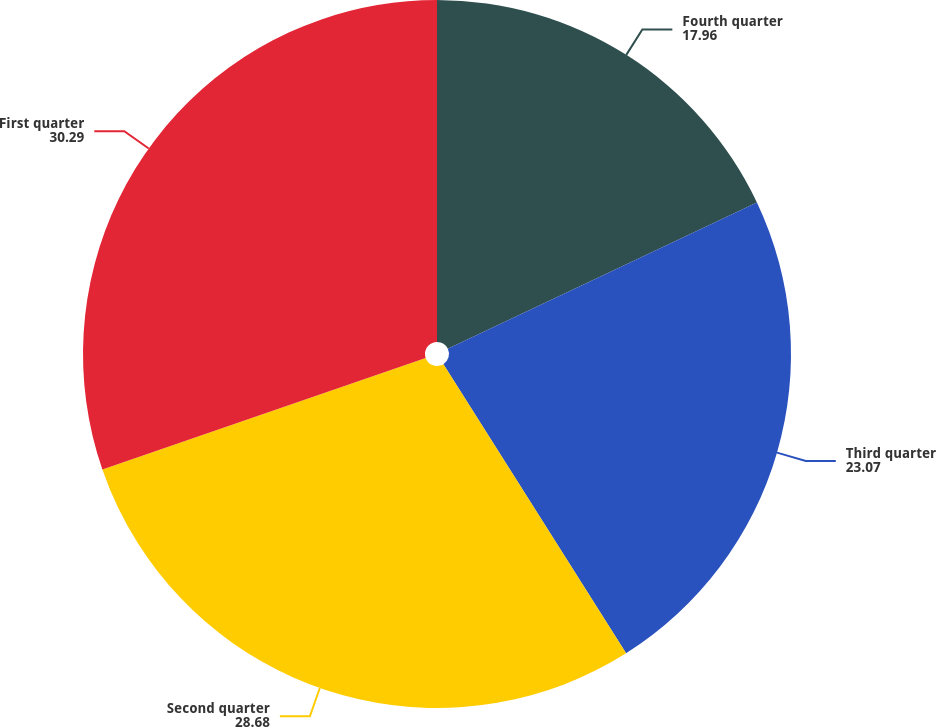Convert chart to OTSL. <chart><loc_0><loc_0><loc_500><loc_500><pie_chart><fcel>Fourth quarter<fcel>Third quarter<fcel>Second quarter<fcel>First quarter<nl><fcel>17.96%<fcel>23.07%<fcel>28.68%<fcel>30.29%<nl></chart> 